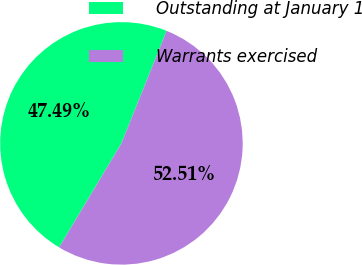<chart> <loc_0><loc_0><loc_500><loc_500><pie_chart><fcel>Outstanding at January 1<fcel>Warrants exercised<nl><fcel>47.49%<fcel>52.51%<nl></chart> 